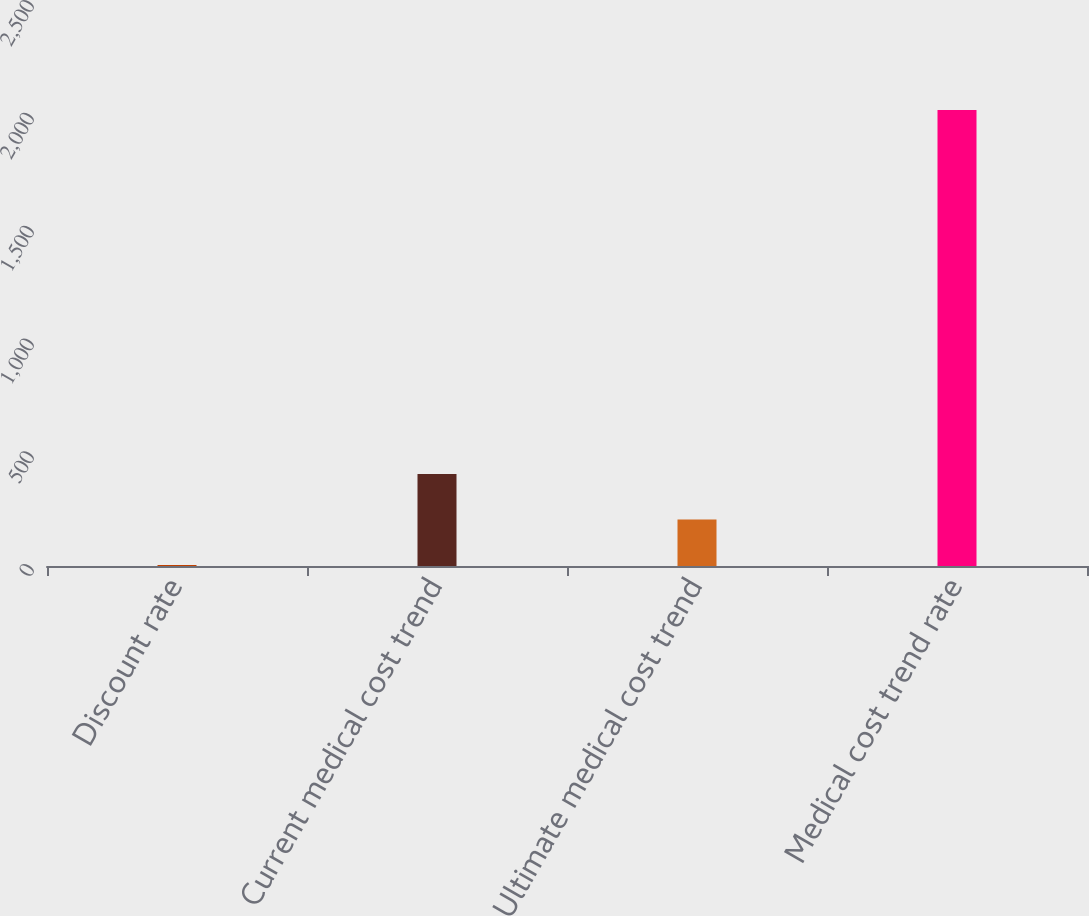<chart> <loc_0><loc_0><loc_500><loc_500><bar_chart><fcel>Discount rate<fcel>Current medical cost trend<fcel>Ultimate medical cost trend<fcel>Medical cost trend rate<nl><fcel>4.6<fcel>407.88<fcel>206.24<fcel>2021<nl></chart> 